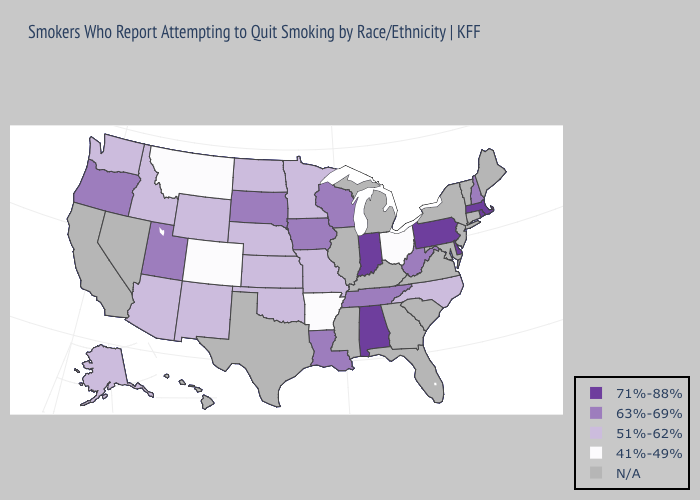Does the map have missing data?
Concise answer only. Yes. What is the lowest value in the USA?
Short answer required. 41%-49%. Name the states that have a value in the range 63%-69%?
Give a very brief answer. Iowa, Louisiana, New Hampshire, Oregon, South Dakota, Tennessee, Utah, West Virginia, Wisconsin. Does Arkansas have the lowest value in the USA?
Concise answer only. Yes. Name the states that have a value in the range 63%-69%?
Quick response, please. Iowa, Louisiana, New Hampshire, Oregon, South Dakota, Tennessee, Utah, West Virginia, Wisconsin. What is the value of Wyoming?
Answer briefly. 51%-62%. Name the states that have a value in the range 71%-88%?
Quick response, please. Alabama, Delaware, Indiana, Massachusetts, Pennsylvania, Rhode Island. Name the states that have a value in the range 41%-49%?
Keep it brief. Arkansas, Colorado, Montana, Ohio. Does New Hampshire have the lowest value in the Northeast?
Short answer required. Yes. What is the value of North Carolina?
Answer briefly. 51%-62%. Name the states that have a value in the range 71%-88%?
Keep it brief. Alabama, Delaware, Indiana, Massachusetts, Pennsylvania, Rhode Island. 